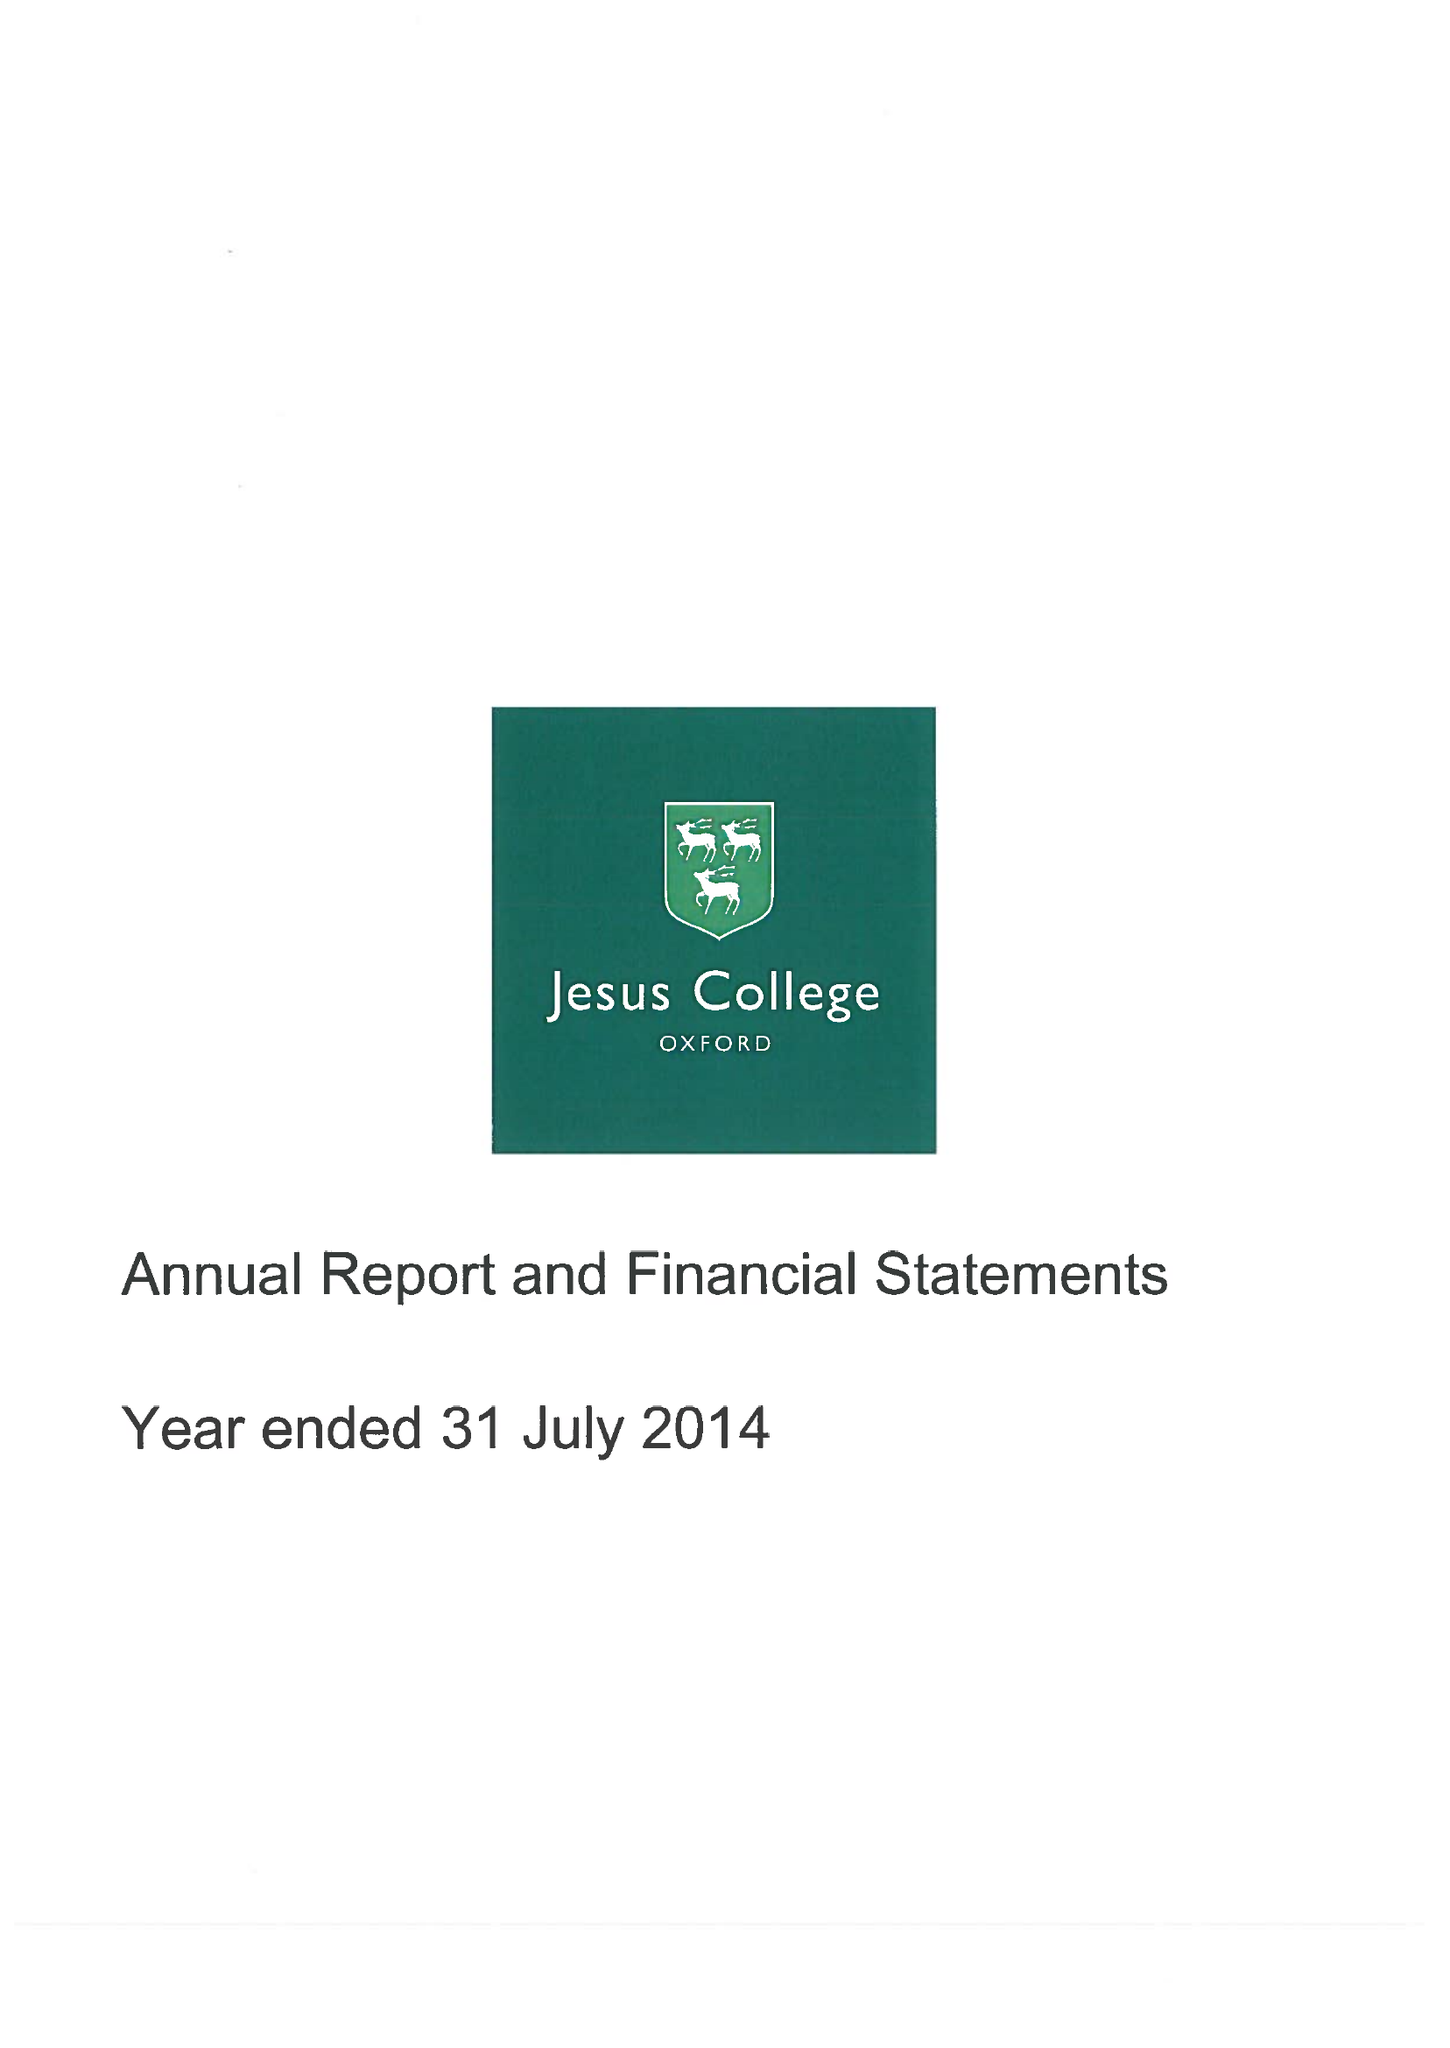What is the value for the address__street_line?
Answer the question using a single word or phrase. TURL STREET 